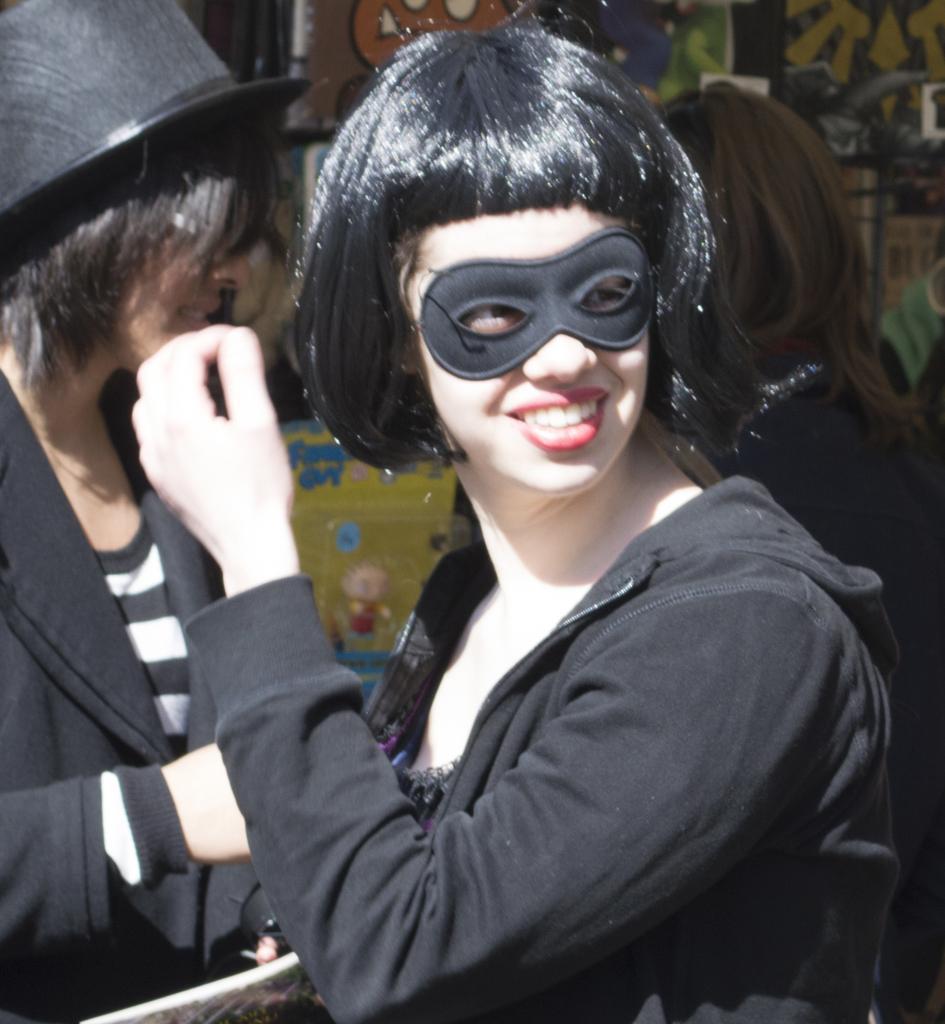Can you describe this image briefly? In this image in the foreground there is one woman who is wearing a mask and smiling, in the background there are two women and there is a wall. On the wall there is some art and some other objects. 